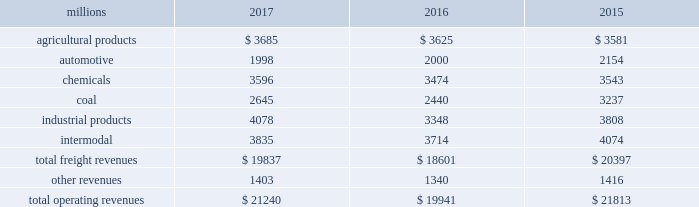Notes to the consolidated financial statements union pacific corporation and subsidiary companies for purposes of this report , unless the context otherwise requires , all references herein to the 201ccorporation 201d , 201ccompany 201d , 201cupc 201d , 201cwe 201d , 201cus 201d , and 201cour 201d mean union pacific corporation and its subsidiaries , including union pacific railroad company , which will be separately referred to herein as 201cuprr 201d or the 201crailroad 201d .
Nature of operations operations and segmentation 2013 we are a class i railroad operating in the u.s .
Our network includes 32122 route miles , linking pacific coast and gulf coast ports with the midwest and eastern u.s .
Gateways and providing several corridors to key mexican gateways .
We own 26042 miles and operate on the remainder pursuant to trackage rights or leases .
We serve the western two-thirds of the country and maintain coordinated schedules with other rail carriers for the handling of freight to and from the atlantic coast , the pacific coast , the southeast , the southwest , canada , and mexico .
Export and import traffic is moved through gulf coast and pacific coast ports and across the mexican and canadian borders .
The railroad , along with its subsidiaries and rail affiliates , is our one reportable operating segment .
Although we provide and analyze revenue by commodity group , we treat the financial results of the railroad as one segment due to the integrated nature of our rail network .
The table provides freight revenue by commodity group: .
Although our revenues are principally derived from customers domiciled in the u.s. , the ultimate points of origination or destination for some products we transport are outside the u.s .
Each of our commodity groups includes revenue from shipments to and from mexico .
Included in the above table are freight revenues from our mexico business which amounted to $ 2.3 billion in 2017 , $ 2.2 billion in 2016 , and $ 2.2 billion in 2015 .
Basis of presentation 2013 the consolidated financial statements are presented in accordance with accounting principles generally accepted in the u.s .
( gaap ) as codified in the financial accounting standards board ( fasb ) accounting standards codification ( asc ) .
Significant accounting policies principles of consolidation 2013 the consolidated financial statements include the accounts of union pacific corporation and all of its subsidiaries .
Investments in affiliated companies ( 20% ( 20 % ) to 50% ( 50 % ) owned ) are accounted for using the equity method of accounting .
All intercompany transactions are eliminated .
We currently have no less than majority-owned investments that require consolidation under variable interest entity requirements .
Cash and cash equivalents 2013 cash equivalents consist of investments with original maturities of three months or less .
Accounts receivable 2013 accounts receivable includes receivables reduced by an allowance for doubtful accounts .
The allowance is based upon historical losses , credit worthiness of customers , and current economic conditions .
Receivables not expected to be collected in one year and the associated allowances are classified as other assets in our consolidated statements of financial position. .
In 2017 what was the percent of the total operating revenues that was attributable to industrial products? 
Computations: (4078 / 21240)
Answer: 0.192. Notes to the consolidated financial statements union pacific corporation and subsidiary companies for purposes of this report , unless the context otherwise requires , all references herein to the 201ccorporation 201d , 201ccompany 201d , 201cupc 201d , 201cwe 201d , 201cus 201d , and 201cour 201d mean union pacific corporation and its subsidiaries , including union pacific railroad company , which will be separately referred to herein as 201cuprr 201d or the 201crailroad 201d .
Nature of operations operations and segmentation 2013 we are a class i railroad operating in the u.s .
Our network includes 32122 route miles , linking pacific coast and gulf coast ports with the midwest and eastern u.s .
Gateways and providing several corridors to key mexican gateways .
We own 26042 miles and operate on the remainder pursuant to trackage rights or leases .
We serve the western two-thirds of the country and maintain coordinated schedules with other rail carriers for the handling of freight to and from the atlantic coast , the pacific coast , the southeast , the southwest , canada , and mexico .
Export and import traffic is moved through gulf coast and pacific coast ports and across the mexican and canadian borders .
The railroad , along with its subsidiaries and rail affiliates , is our one reportable operating segment .
Although we provide and analyze revenue by commodity group , we treat the financial results of the railroad as one segment due to the integrated nature of our rail network .
The table provides freight revenue by commodity group: .
Although our revenues are principally derived from customers domiciled in the u.s. , the ultimate points of origination or destination for some products we transport are outside the u.s .
Each of our commodity groups includes revenue from shipments to and from mexico .
Included in the above table are freight revenues from our mexico business which amounted to $ 2.3 billion in 2017 , $ 2.2 billion in 2016 , and $ 2.2 billion in 2015 .
Basis of presentation 2013 the consolidated financial statements are presented in accordance with accounting principles generally accepted in the u.s .
( gaap ) as codified in the financial accounting standards board ( fasb ) accounting standards codification ( asc ) .
Significant accounting policies principles of consolidation 2013 the consolidated financial statements include the accounts of union pacific corporation and all of its subsidiaries .
Investments in affiliated companies ( 20% ( 20 % ) to 50% ( 50 % ) owned ) are accounted for using the equity method of accounting .
All intercompany transactions are eliminated .
We currently have no less than majority-owned investments that require consolidation under variable interest entity requirements .
Cash and cash equivalents 2013 cash equivalents consist of investments with original maturities of three months or less .
Accounts receivable 2013 accounts receivable includes receivables reduced by an allowance for doubtful accounts .
The allowance is based upon historical losses , credit worthiness of customers , and current economic conditions .
Receivables not expected to be collected in one year and the associated allowances are classified as other assets in our consolidated statements of financial position. .
What percentage of total freight revenues was the agricultural commodity group in 2017? 
Computations: (3685 / 19837)
Answer: 0.18576. 